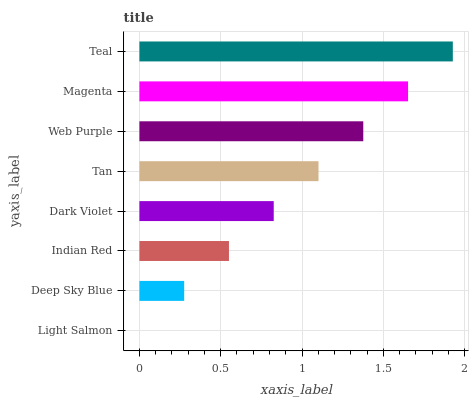Is Light Salmon the minimum?
Answer yes or no. Yes. Is Teal the maximum?
Answer yes or no. Yes. Is Deep Sky Blue the minimum?
Answer yes or no. No. Is Deep Sky Blue the maximum?
Answer yes or no. No. Is Deep Sky Blue greater than Light Salmon?
Answer yes or no. Yes. Is Light Salmon less than Deep Sky Blue?
Answer yes or no. Yes. Is Light Salmon greater than Deep Sky Blue?
Answer yes or no. No. Is Deep Sky Blue less than Light Salmon?
Answer yes or no. No. Is Tan the high median?
Answer yes or no. Yes. Is Dark Violet the low median?
Answer yes or no. Yes. Is Light Salmon the high median?
Answer yes or no. No. Is Deep Sky Blue the low median?
Answer yes or no. No. 